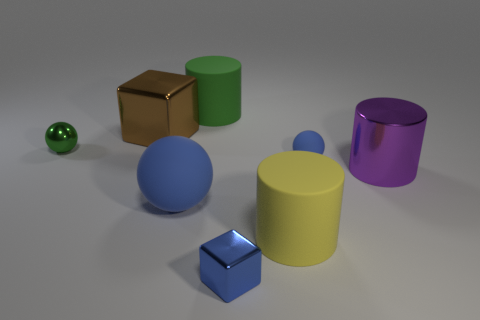Subtract all shiny spheres. How many spheres are left? 2 Add 1 brown objects. How many objects exist? 9 Subtract all purple cylinders. How many cylinders are left? 2 Subtract 0 red spheres. How many objects are left? 8 Subtract all cylinders. How many objects are left? 5 Subtract all blue balls. Subtract all yellow cylinders. How many balls are left? 1 Subtract all purple balls. How many gray cylinders are left? 0 Subtract all tiny yellow shiny things. Subtract all big things. How many objects are left? 3 Add 4 big green matte cylinders. How many big green matte cylinders are left? 5 Add 6 yellow objects. How many yellow objects exist? 7 